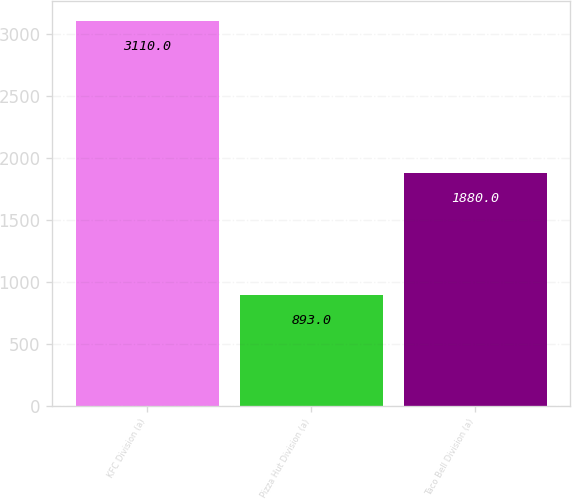Convert chart. <chart><loc_0><loc_0><loc_500><loc_500><bar_chart><fcel>KFC Division (a)<fcel>Pizza Hut Division (a)<fcel>Taco Bell Division (a)<nl><fcel>3110<fcel>893<fcel>1880<nl></chart> 